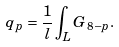<formula> <loc_0><loc_0><loc_500><loc_500>q _ { p } = \frac { 1 } { l } \int _ { L } G _ { 8 - p } .</formula> 